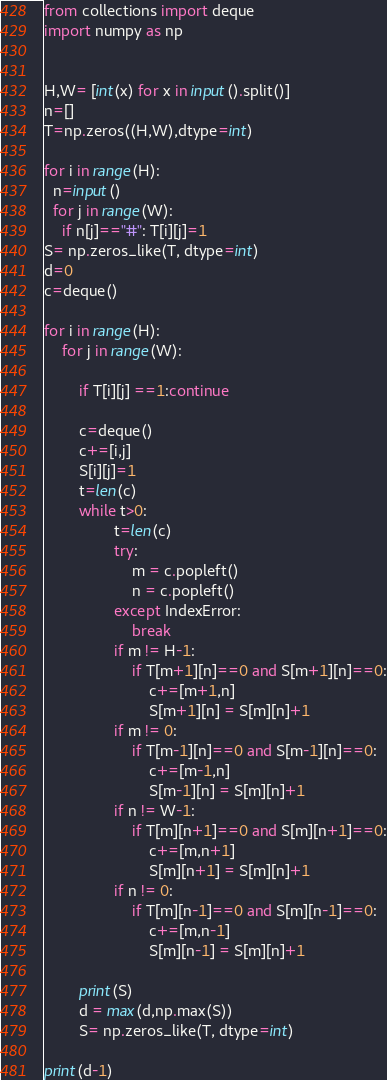Convert code to text. <code><loc_0><loc_0><loc_500><loc_500><_Python_>from collections import deque
import numpy as np
 
 
H,W= [int(x) for x in input().split()]
n=[]
T=np.zeros((H,W),dtype=int)

for i in range(H):
  n=input()
  for j in range(W):
    if n[j]=="#": T[i][j]=1
S= np.zeros_like(T, dtype=int)
d=0
c=deque()

for i in range(H):
    for j in range(W):
         
        if T[i][j] ==1:continue

        c=deque()    
        c+=[i,j]
        S[i][j]=1
        t=len(c)
        while t>0:
                t=len(c)
                try:
                    m = c.popleft()
                    n = c.popleft()
                except IndexError:
                    break
                if m != H-1:
                    if T[m+1][n]==0 and S[m+1][n]==0:
                        c+=[m+1,n]
                        S[m+1][n] = S[m][n]+1
                if m != 0:
                    if T[m-1][n]==0 and S[m-1][n]==0:
                        c+=[m-1,n] 
                        S[m-1][n] = S[m][n]+1
                if n != W-1:
                    if T[m][n+1]==0 and S[m][n+1]==0:
                        c+=[m,n+1]
                        S[m][n+1] = S[m][n]+1
                if n != 0:
                    if T[m][n-1]==0 and S[m][n-1]==0:
                        c+=[m,n-1]
                        S[m][n-1] = S[m][n]+1
                
        print(S)
        d = max(d,np.max(S))
        S= np.zeros_like(T, dtype=int)
        
print(d-1) </code> 